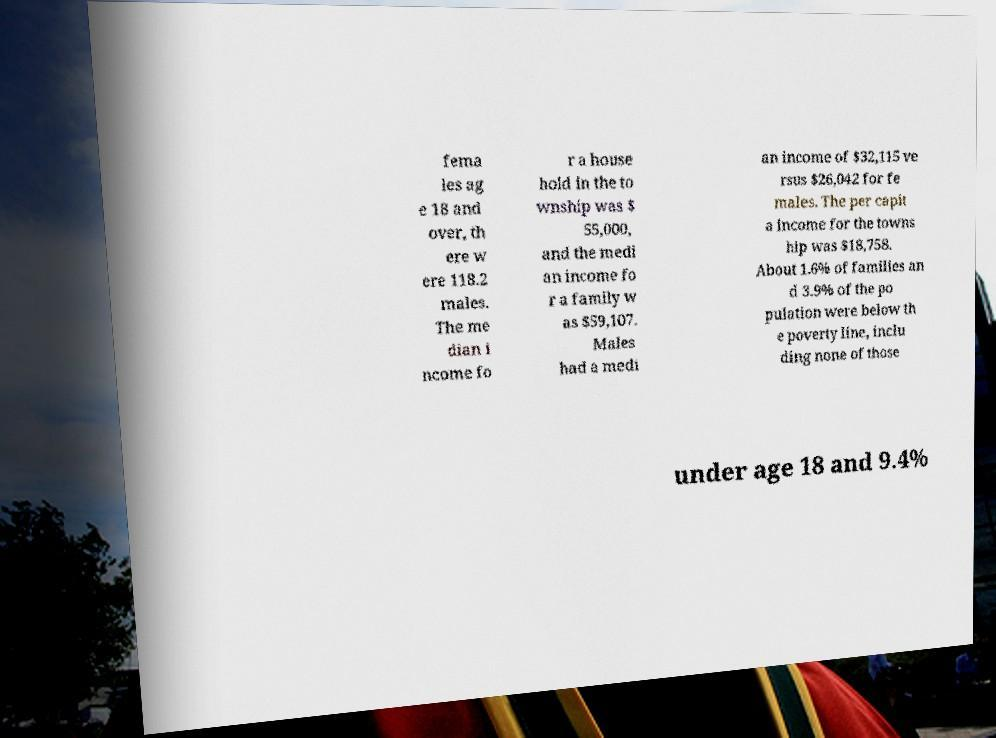There's text embedded in this image that I need extracted. Can you transcribe it verbatim? fema les ag e 18 and over, th ere w ere 118.2 males. The me dian i ncome fo r a house hold in the to wnship was $ 55,000, and the medi an income fo r a family w as $59,107. Males had a medi an income of $32,115 ve rsus $26,042 for fe males. The per capit a income for the towns hip was $18,758. About 1.6% of families an d 3.9% of the po pulation were below th e poverty line, inclu ding none of those under age 18 and 9.4% 